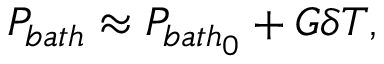Convert formula to latex. <formula><loc_0><loc_0><loc_500><loc_500>P _ { b a t h } \approx P _ { b a t h _ { 0 } } + G \delta T ,</formula> 